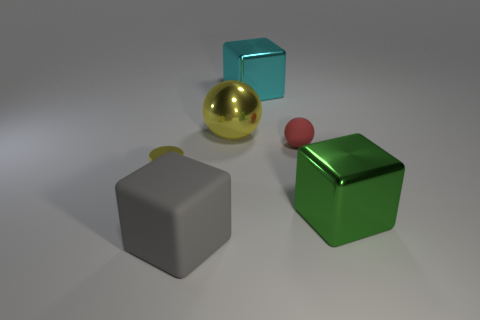What material is the yellow object that is to the right of the small cylinder that is in front of the big block behind the tiny yellow thing made of?
Make the answer very short. Metal. There is a matte thing that is on the right side of the shiny sphere; does it have the same size as the gray block?
Offer a very short reply. No. What material is the thing that is in front of the large green metal block?
Make the answer very short. Rubber. Are there more tiny purple cylinders than tiny matte balls?
Your response must be concise. No. What number of things are either objects that are to the left of the big yellow metallic object or big yellow objects?
Offer a very short reply. 3. How many big cyan shiny objects are behind the yellow shiny thing behind the small red thing?
Your answer should be compact. 1. What is the size of the metallic object that is in front of the small thing left of the sphere on the left side of the red rubber object?
Provide a short and direct response. Large. There is a object that is in front of the big green object; is its color the same as the tiny rubber ball?
Give a very brief answer. No. The cyan thing that is the same shape as the green thing is what size?
Your answer should be very brief. Large. What number of things are either large blocks behind the yellow cylinder or blocks in front of the big green metal thing?
Give a very brief answer. 2. 